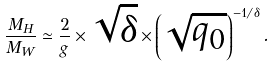<formula> <loc_0><loc_0><loc_500><loc_500>\frac { M _ { H } } { M _ { W } } \simeq \frac { 2 } { g } \times \sqrt { \delta } \times \left ( \sqrt { q _ { 0 } } \right ) ^ { - 1 / \delta } .</formula> 